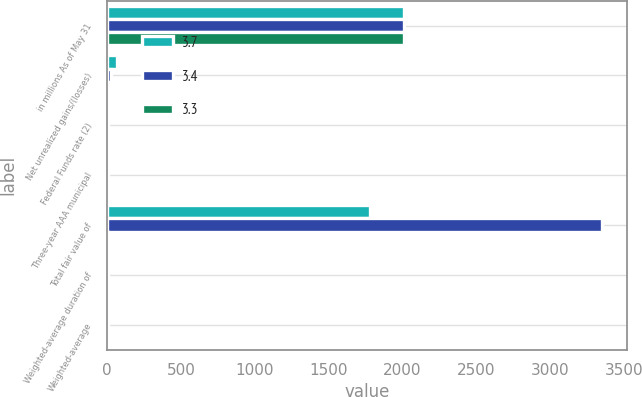Convert chart. <chart><loc_0><loc_0><loc_500><loc_500><stacked_bar_chart><ecel><fcel>in millions As of May 31<fcel>Net unrealized gains/(losses)<fcel>Federal Funds rate (2)<fcel>Three-year AAA municipal<fcel>Total fair value of<fcel>Weighted-average duration of<fcel>Weighted-average<nl><fcel>3.7<fcel>2009<fcel>66.7<fcel>0.25<fcel>1.35<fcel>1780.9<fcel>2.5<fcel>3.3<nl><fcel>3.4<fcel>2008<fcel>24.8<fcel>2<fcel>2.65<fcel>3353.5<fcel>2.7<fcel>3.4<nl><fcel>3.3<fcel>2007<fcel>14.9<fcel>5.25<fcel>3.71<fcel>3.705<fcel>2.5<fcel>3.7<nl></chart> 